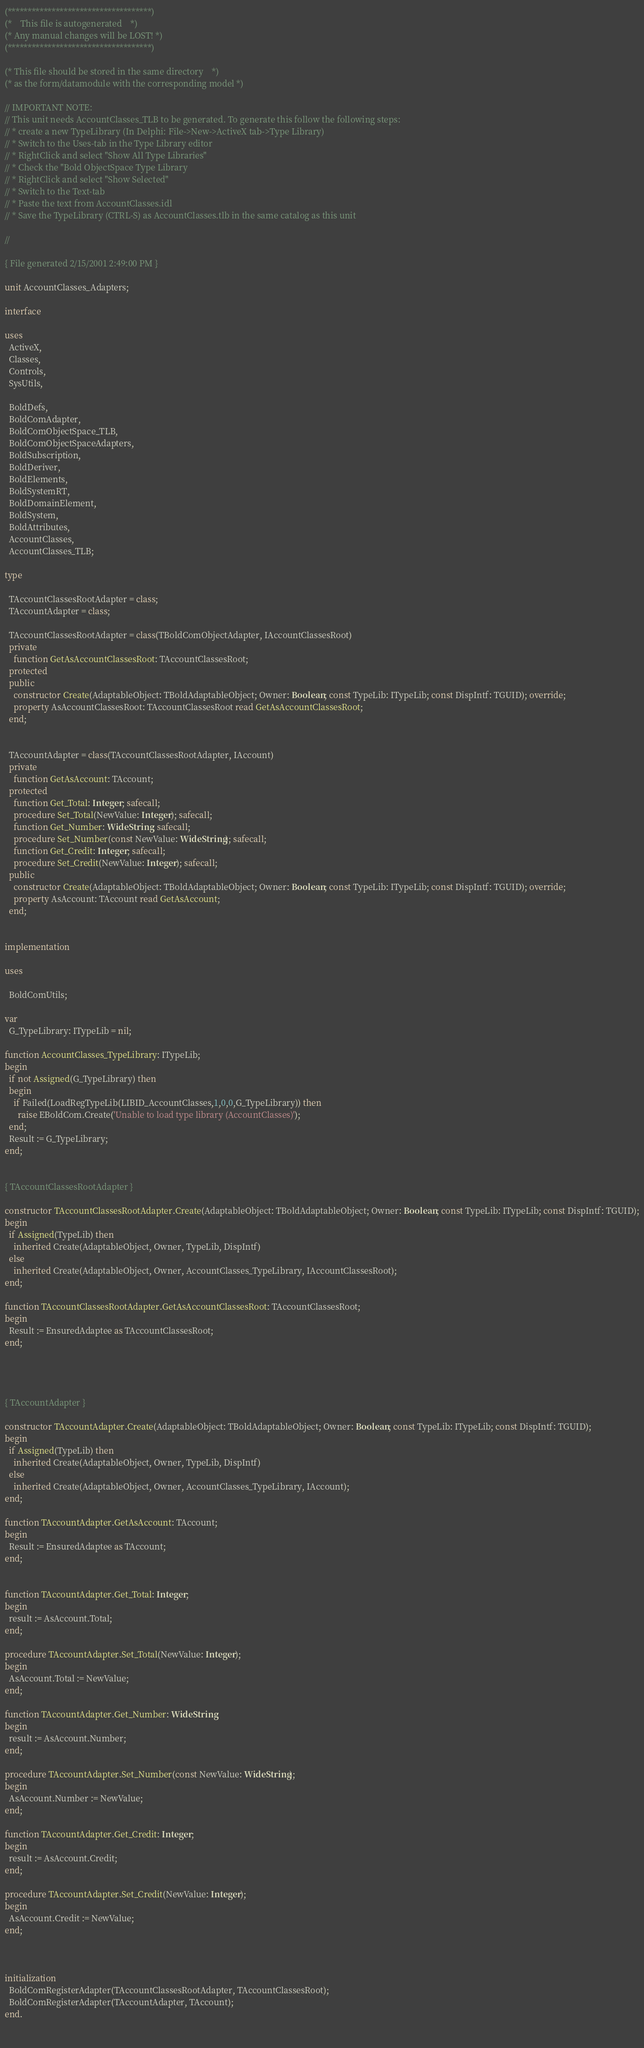<code> <loc_0><loc_0><loc_500><loc_500><_Pascal_>(************************************)
(*    This file is autogenerated    *)
(* Any manual changes will be LOST! *)
(************************************)

(* This file should be stored in the same directory    *)
(* as the form/datamodule with the corresponding model *)

// IMPORTANT NOTE:
// This unit needs AccountClasses_TLB to be generated. To generate this follow the following steps:
// * create a new TypeLibrary (In Delphi: File->New->ActiveX tab->Type Library)
// * Switch to the Uses-tab in the Type Library editor
// * RightClick and select "Show All Type Libraries"
// * Check the "Bold ObjectSpace Type Library
// * RightClick and select "Show Selected"
// * Switch to the Text-tab
// * Paste the text from AccountClasses.idl
// * Save the TypeLibrary (CTRL-S) as AccountClasses.tlb in the same catalog as this unit

// 

{ File generated 2/15/2001 2:49:00 PM }

unit AccountClasses_Adapters;

interface

uses
  ActiveX,
  Classes,
  Controls, 
  SysUtils,
  
  BoldDefs,
  BoldComAdapter,
  BoldComObjectSpace_TLB,
  BoldComObjectSpaceAdapters,
  BoldSubscription,
  BoldDeriver,
  BoldElements,
  BoldSystemRT,
  BoldDomainElement,
  BoldSystem,
  BoldAttributes,
  AccountClasses,
  AccountClasses_TLB;

type

  TAccountClassesRootAdapter = class;
  TAccountAdapter = class;

  TAccountClassesRootAdapter = class(TBoldComObjectAdapter, IAccountClassesRoot)
  private
    function GetAsAccountClassesRoot: TAccountClassesRoot;
  protected
  public
    constructor Create(AdaptableObject: TBoldAdaptableObject; Owner: Boolean; const TypeLib: ITypeLib; const DispIntf: TGUID); override;
    property AsAccountClassesRoot: TAccountClassesRoot read GetAsAccountClassesRoot;
  end;


  TAccountAdapter = class(TAccountClassesRootAdapter, IAccount)
  private
    function GetAsAccount: TAccount;
  protected
    function Get_Total: Integer; safecall;
    procedure Set_Total(NewValue: Integer); safecall;
    function Get_Number: WideString; safecall;
    procedure Set_Number(const NewValue: WideString); safecall;
    function Get_Credit: Integer; safecall;
    procedure Set_Credit(NewValue: Integer); safecall;
  public
    constructor Create(AdaptableObject: TBoldAdaptableObject; Owner: Boolean; const TypeLib: ITypeLib; const DispIntf: TGUID); override;
    property AsAccount: TAccount read GetAsAccount;
  end;


implementation

uses
  
  BoldComUtils;

var
  G_TypeLibrary: ITypeLib = nil;

function AccountClasses_TypeLibrary: ITypeLib;
begin
  if not Assigned(G_TypeLibrary) then
  begin
    if Failed(LoadRegTypeLib(LIBID_AccountClasses,1,0,0,G_TypeLibrary)) then
      raise EBoldCom.Create('Unable to load type library (AccountClasses)');
  end;
  Result := G_TypeLibrary;
end;


{ TAccountClassesRootAdapter }

constructor TAccountClassesRootAdapter.Create(AdaptableObject: TBoldAdaptableObject; Owner: Boolean; const TypeLib: ITypeLib; const DispIntf: TGUID);
begin
  if Assigned(TypeLib) then
    inherited Create(AdaptableObject, Owner, TypeLib, DispIntf)
  else
    inherited Create(AdaptableObject, Owner, AccountClasses_TypeLibrary, IAccountClassesRoot);
end;

function TAccountClassesRootAdapter.GetAsAccountClassesRoot: TAccountClassesRoot;
begin
  Result := EnsuredAdaptee as TAccountClassesRoot;
end;




{ TAccountAdapter }

constructor TAccountAdapter.Create(AdaptableObject: TBoldAdaptableObject; Owner: Boolean; const TypeLib: ITypeLib; const DispIntf: TGUID);
begin
  if Assigned(TypeLib) then
    inherited Create(AdaptableObject, Owner, TypeLib, DispIntf)
  else
    inherited Create(AdaptableObject, Owner, AccountClasses_TypeLibrary, IAccount);
end;

function TAccountAdapter.GetAsAccount: TAccount;
begin
  Result := EnsuredAdaptee as TAccount;
end;


function TAccountAdapter.Get_Total: Integer;
begin
  result := AsAccount.Total;
end;

procedure TAccountAdapter.Set_Total(NewValue: Integer);
begin
  AsAccount.Total := NewValue;
end;

function TAccountAdapter.Get_Number: WideString;
begin
  result := AsAccount.Number;
end;

procedure TAccountAdapter.Set_Number(const NewValue: WideString);
begin
  AsAccount.Number := NewValue;
end;

function TAccountAdapter.Get_Credit: Integer;
begin
  result := AsAccount.Credit;
end;

procedure TAccountAdapter.Set_Credit(NewValue: Integer);
begin
  AsAccount.Credit := NewValue;
end;



initialization
  BoldComRegisterAdapter(TAccountClassesRootAdapter, TAccountClassesRoot);
  BoldComRegisterAdapter(TAccountAdapter, TAccount);
end.

 </code> 